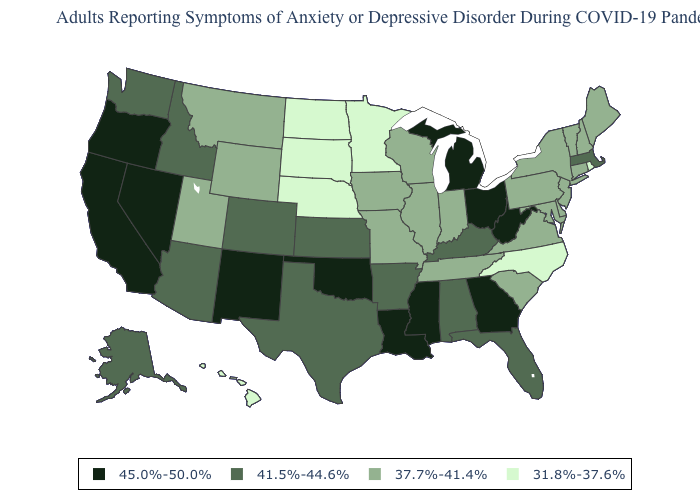Name the states that have a value in the range 45.0%-50.0%?
Give a very brief answer. California, Georgia, Louisiana, Michigan, Mississippi, Nevada, New Mexico, Ohio, Oklahoma, Oregon, West Virginia. Is the legend a continuous bar?
Short answer required. No. What is the value of New Mexico?
Concise answer only. 45.0%-50.0%. Does Montana have the highest value in the USA?
Be succinct. No. Which states have the highest value in the USA?
Quick response, please. California, Georgia, Louisiana, Michigan, Mississippi, Nevada, New Mexico, Ohio, Oklahoma, Oregon, West Virginia. Does the first symbol in the legend represent the smallest category?
Concise answer only. No. How many symbols are there in the legend?
Concise answer only. 4. What is the value of Maine?
Be succinct. 37.7%-41.4%. Name the states that have a value in the range 37.7%-41.4%?
Give a very brief answer. Connecticut, Delaware, Illinois, Indiana, Iowa, Maine, Maryland, Missouri, Montana, New Hampshire, New Jersey, New York, Pennsylvania, South Carolina, Tennessee, Utah, Vermont, Virginia, Wisconsin, Wyoming. Does Nebraska have the lowest value in the USA?
Short answer required. Yes. Which states hav the highest value in the South?
Concise answer only. Georgia, Louisiana, Mississippi, Oklahoma, West Virginia. What is the value of Arizona?
Be succinct. 41.5%-44.6%. Does Georgia have the highest value in the South?
Concise answer only. Yes. Among the states that border Kentucky , which have the highest value?
Keep it brief. Ohio, West Virginia. Which states have the lowest value in the MidWest?
Concise answer only. Minnesota, Nebraska, North Dakota, South Dakota. 